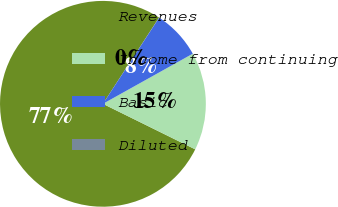Convert chart. <chart><loc_0><loc_0><loc_500><loc_500><pie_chart><fcel>Revenues<fcel>Income from continuing<fcel>Basic<fcel>Diluted<nl><fcel>76.89%<fcel>15.39%<fcel>7.7%<fcel>0.02%<nl></chart> 